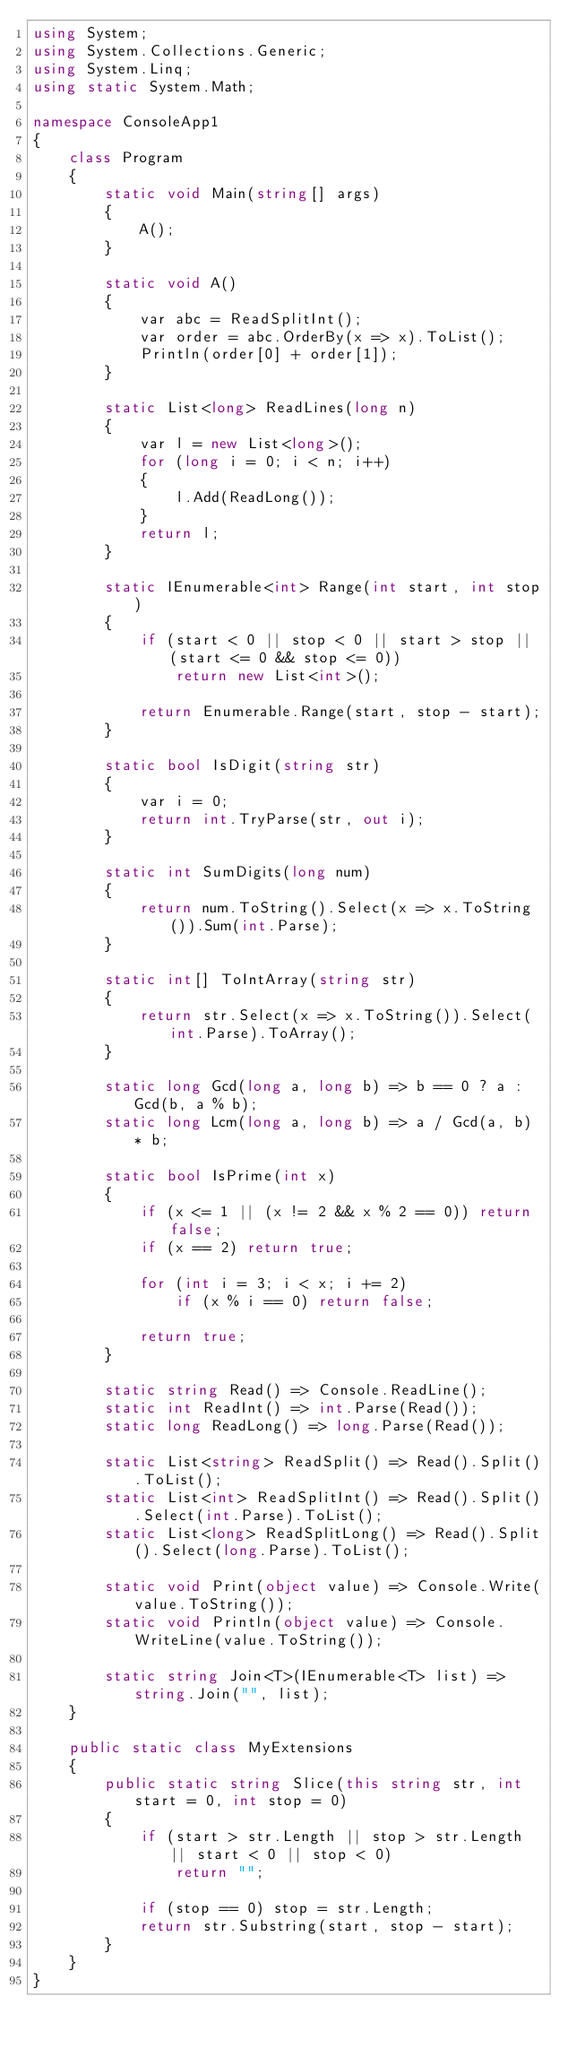<code> <loc_0><loc_0><loc_500><loc_500><_C#_>using System;
using System.Collections.Generic;
using System.Linq;
using static System.Math;

namespace ConsoleApp1
{
    class Program
    {
        static void Main(string[] args)
        {
            A();
        }

        static void A()
        {
            var abc = ReadSplitInt();
            var order = abc.OrderBy(x => x).ToList();
            Println(order[0] + order[1]);
        }

        static List<long> ReadLines(long n)
        {
            var l = new List<long>();
            for (long i = 0; i < n; i++)
            {
                l.Add(ReadLong());
            }
            return l;
        }

        static IEnumerable<int> Range(int start, int stop)
        {
            if (start < 0 || stop < 0 || start > stop || (start <= 0 && stop <= 0))
                return new List<int>();

            return Enumerable.Range(start, stop - start);
        }

        static bool IsDigit(string str)
        {
            var i = 0;
            return int.TryParse(str, out i);
        }

        static int SumDigits(long num)
        {
            return num.ToString().Select(x => x.ToString()).Sum(int.Parse);
        }

        static int[] ToIntArray(string str)
        {
            return str.Select(x => x.ToString()).Select(int.Parse).ToArray();
        }

        static long Gcd(long a, long b) => b == 0 ? a : Gcd(b, a % b);
        static long Lcm(long a, long b) => a / Gcd(a, b) * b;

        static bool IsPrime(int x)
        {
            if (x <= 1 || (x != 2 && x % 2 == 0)) return false;
            if (x == 2) return true;

            for (int i = 3; i < x; i += 2)
                if (x % i == 0) return false;

            return true;
        }

        static string Read() => Console.ReadLine();
        static int ReadInt() => int.Parse(Read());
        static long ReadLong() => long.Parse(Read());

        static List<string> ReadSplit() => Read().Split().ToList();
        static List<int> ReadSplitInt() => Read().Split().Select(int.Parse).ToList();
        static List<long> ReadSplitLong() => Read().Split().Select(long.Parse).ToList();

        static void Print(object value) => Console.Write(value.ToString());
        static void Println(object value) => Console.WriteLine(value.ToString());

        static string Join<T>(IEnumerable<T> list) => string.Join("", list);
    }

    public static class MyExtensions
    {
        public static string Slice(this string str, int start = 0, int stop = 0)
        {
            if (start > str.Length || stop > str.Length || start < 0 || stop < 0)
                return "";

            if (stop == 0) stop = str.Length;
            return str.Substring(start, stop - start);
        }
    }
}</code> 